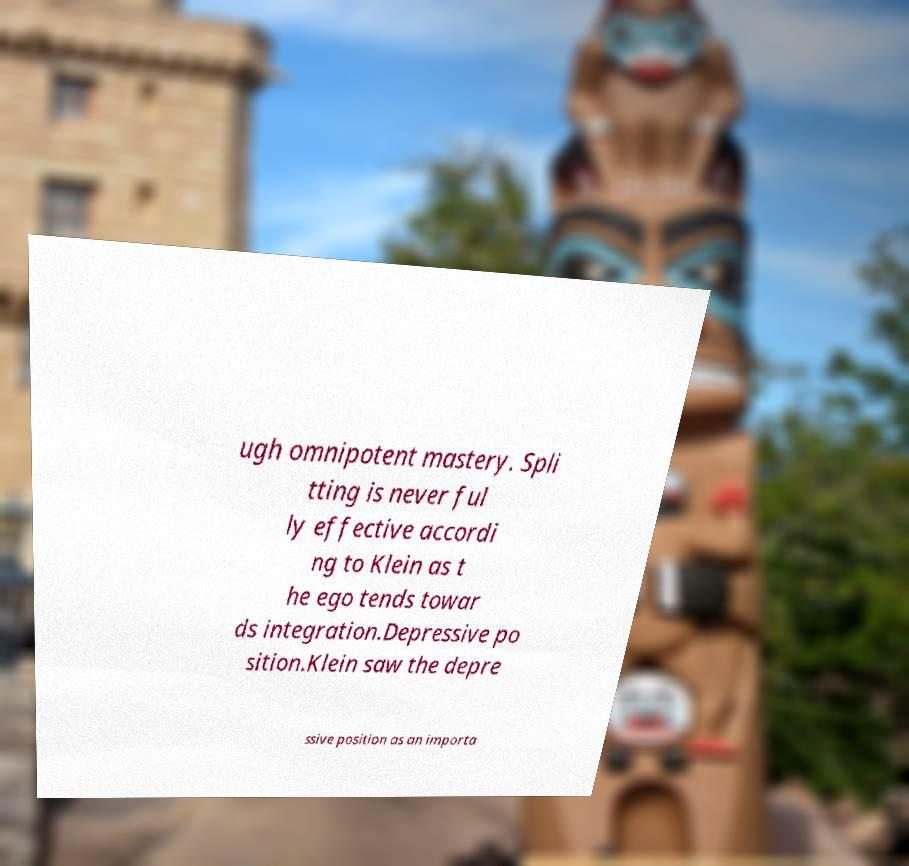Please identify and transcribe the text found in this image. ugh omnipotent mastery. Spli tting is never ful ly effective accordi ng to Klein as t he ego tends towar ds integration.Depressive po sition.Klein saw the depre ssive position as an importa 